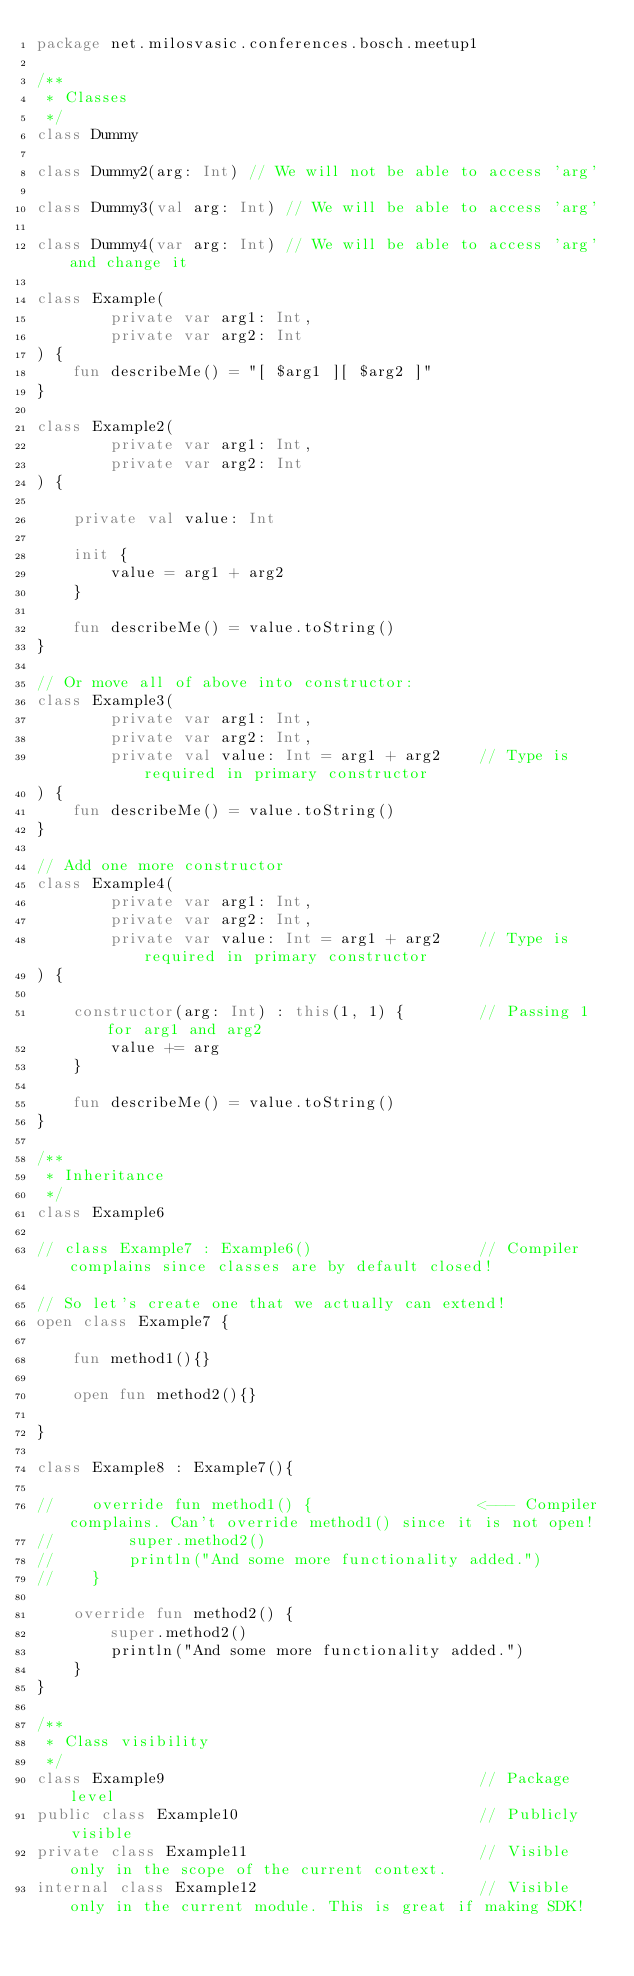Convert code to text. <code><loc_0><loc_0><loc_500><loc_500><_Kotlin_>package net.milosvasic.conferences.bosch.meetup1

/**
 * Classes
 */
class Dummy

class Dummy2(arg: Int) // We will not be able to access 'arg'

class Dummy3(val arg: Int) // We will be able to access 'arg'

class Dummy4(var arg: Int) // We will be able to access 'arg' and change it

class Example(
        private var arg1: Int,
        private var arg2: Int
) {
    fun describeMe() = "[ $arg1 ][ $arg2 ]"
}

class Example2(
        private var arg1: Int,
        private var arg2: Int
) {

    private val value: Int

    init {
        value = arg1 + arg2
    }

    fun describeMe() = value.toString()
}

// Or move all of above into constructor:
class Example3(
        private var arg1: Int,
        private var arg2: Int,
        private val value: Int = arg1 + arg2    // Type is required in primary constructor
) {
    fun describeMe() = value.toString()
}

// Add one more constructor
class Example4(
        private var arg1: Int,
        private var arg2: Int,
        private var value: Int = arg1 + arg2    // Type is required in primary constructor
) {

    constructor(arg: Int) : this(1, 1) {        // Passing 1 for arg1 and arg2
        value += arg
    }

    fun describeMe() = value.toString()
}

/**
 * Inheritance
 */
class Example6

// class Example7 : Example6()                  // Compiler complains since classes are by default closed!

// So let's create one that we actually can extend!
open class Example7 {

    fun method1(){}

    open fun method2(){}

}

class Example8 : Example7(){

//    override fun method1() {                  <--- Compiler complains. Can't override method1() since it is not open!
//        super.method2()
//        println("And some more functionality added.")
//    }

    override fun method2() {
        super.method2()
        println("And some more functionality added.")
    }
}

/**
 * Class visibility
 */
class Example9                                  // Package level
public class Example10                          // Publicly visible
private class Example11                         // Visible only in the scope of the current context.
internal class Example12                        // Visible only in the current module. This is great if making SDK!

</code> 